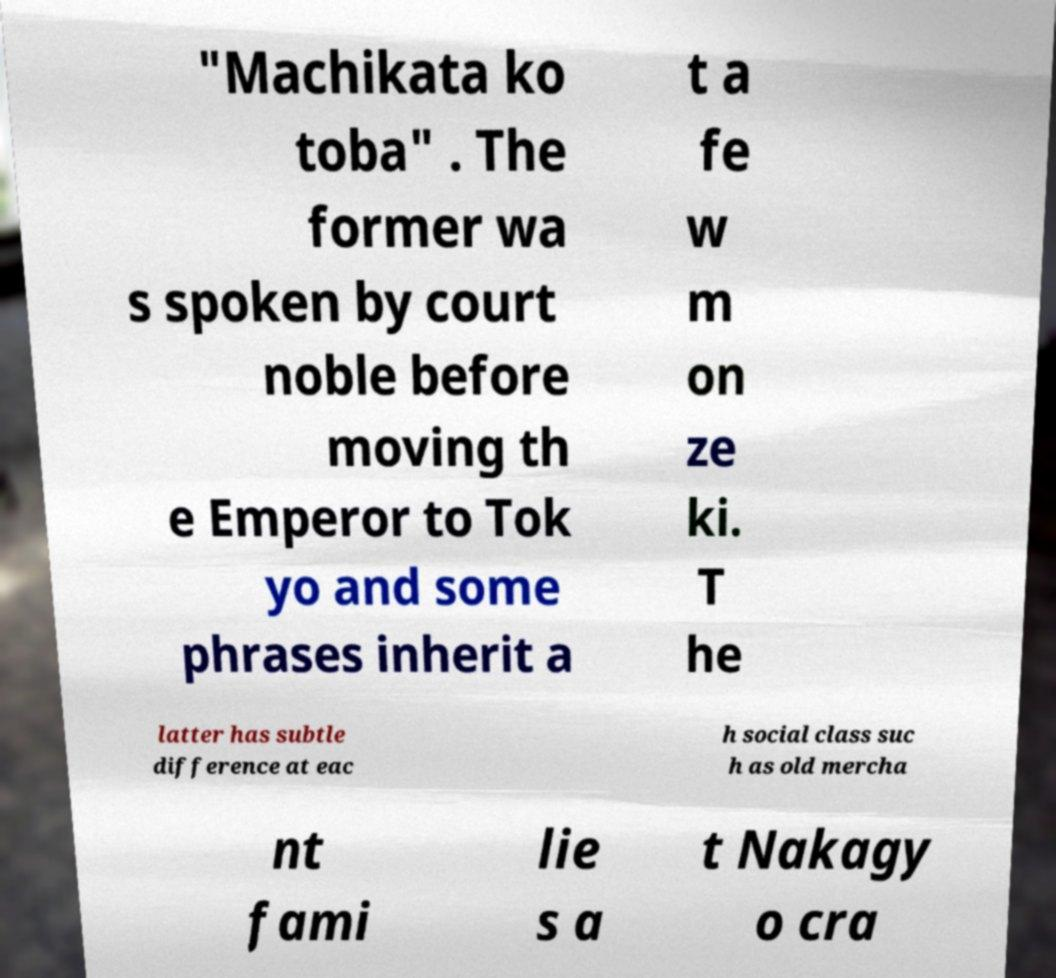For documentation purposes, I need the text within this image transcribed. Could you provide that? "Machikata ko toba" . The former wa s spoken by court noble before moving th e Emperor to Tok yo and some phrases inherit a t a fe w m on ze ki. T he latter has subtle difference at eac h social class suc h as old mercha nt fami lie s a t Nakagy o cra 